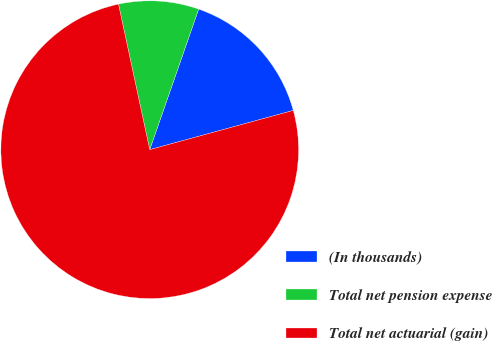<chart> <loc_0><loc_0><loc_500><loc_500><pie_chart><fcel>(In thousands)<fcel>Total net pension expense<fcel>Total net actuarial (gain)<nl><fcel>15.42%<fcel>8.7%<fcel>75.88%<nl></chart> 